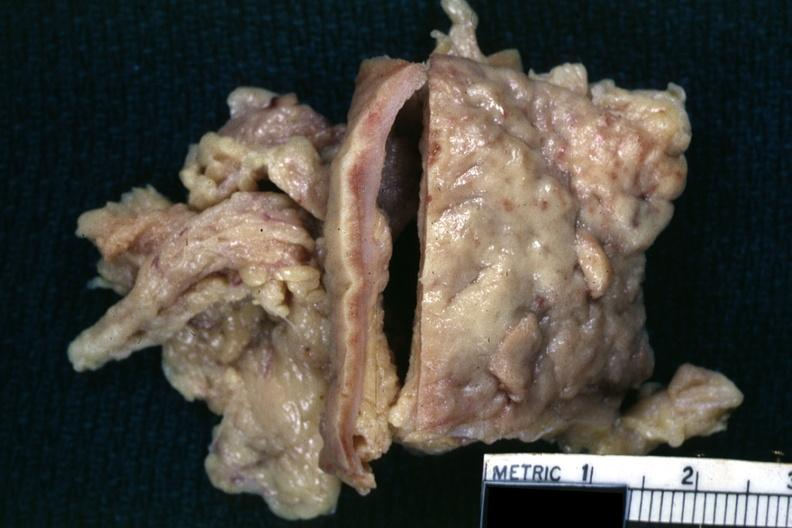what is present?
Answer the question using a single word or phrase. Tuberculosis 